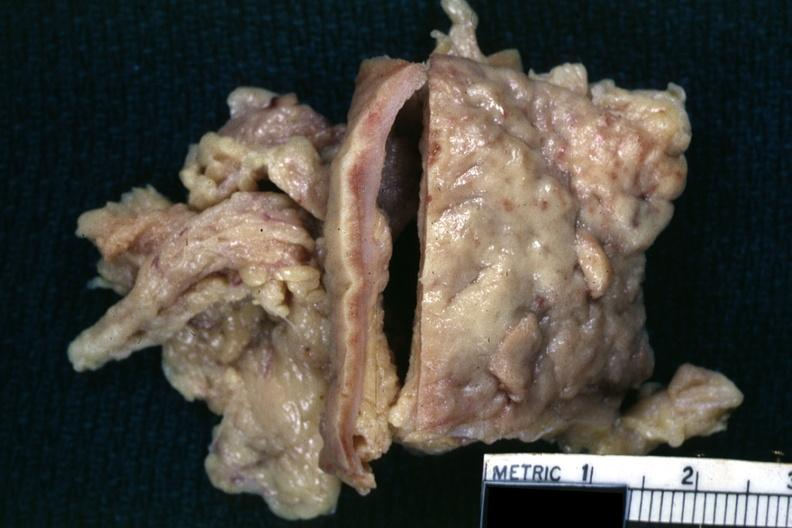what is present?
Answer the question using a single word or phrase. Tuberculosis 